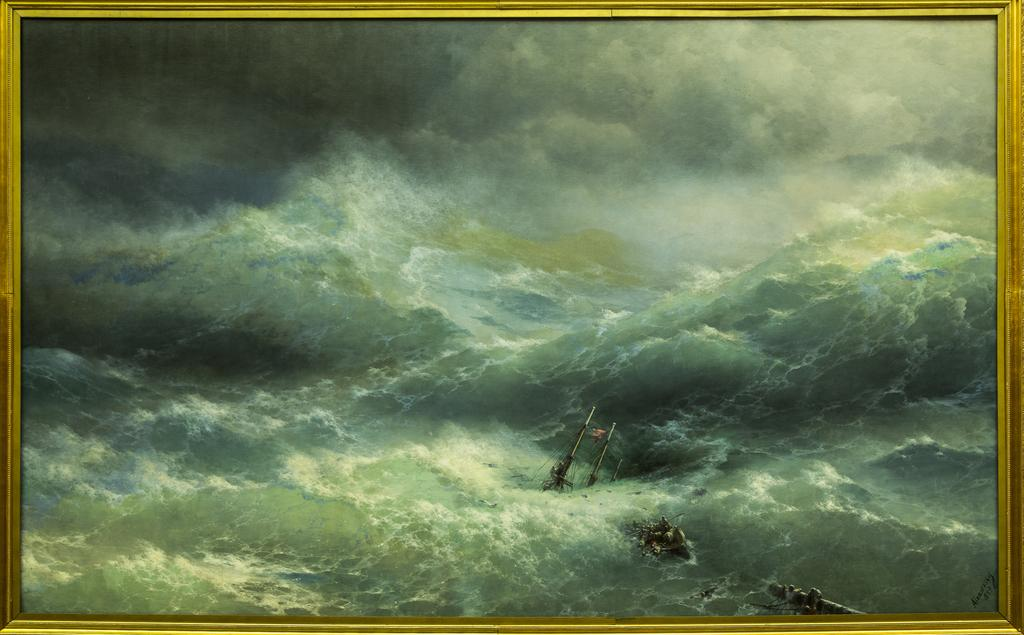What is the main object in the image? There is a frame in the image. What is contained within the frame? The frame contains water. What else can be seen inside the frame? There are objects visible in the frame, as well as the sky. What is the condition of the sky in the image? Clouds are present in the sky, which is visible in the frame. Can you tell me how many bottles of soda are in the basket in the image? There is no basket or soda bottles present in the image. What type of suggestion is being made by the objects in the frame? There is no suggestion being made by the objects in the frame; they are simply visible within the water. 